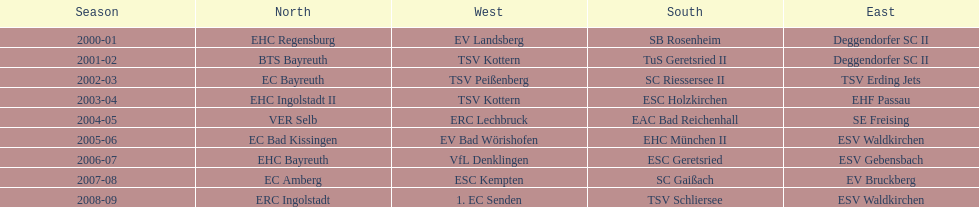Could you help me parse every detail presented in this table? {'header': ['Season', 'North', 'West', 'South', 'East'], 'rows': [['2000-01', 'EHC Regensburg', 'EV Landsberg', 'SB Rosenheim', 'Deggendorfer SC II'], ['2001-02', 'BTS Bayreuth', 'TSV Kottern', 'TuS Geretsried II', 'Deggendorfer SC II'], ['2002-03', 'EC Bayreuth', 'TSV Peißenberg', 'SC Riessersee II', 'TSV Erding Jets'], ['2003-04', 'EHC Ingolstadt II', 'TSV Kottern', 'ESC Holzkirchen', 'EHF Passau'], ['2004-05', 'VER Selb', 'ERC Lechbruck', 'EAC Bad Reichenhall', 'SE Freising'], ['2005-06', 'EC Bad Kissingen', 'EV Bad Wörishofen', 'EHC München II', 'ESV Waldkirchen'], ['2006-07', 'EHC Bayreuth', 'VfL Denklingen', 'ESC Geretsried', 'ESV Gebensbach'], ['2007-08', 'EC Amberg', 'ESC Kempten', 'SC Gaißach', 'EV Bruckberg'], ['2008-09', 'ERC Ingolstadt', '1. EC Senden', 'TSV Schliersee', 'ESV Waldkirchen']]} The last team to win the west? 1. EC Senden. 